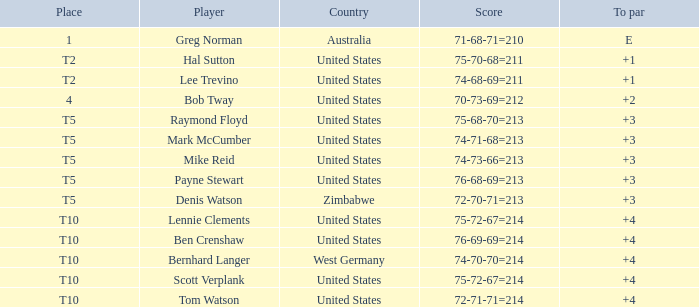Who is the participant with a +3 to par and a 74-71-68=213 score? Mark McCumber. 